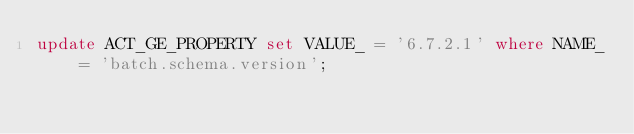Convert code to text. <code><loc_0><loc_0><loc_500><loc_500><_SQL_>update ACT_GE_PROPERTY set VALUE_ = '6.7.2.1' where NAME_ = 'batch.schema.version';
</code> 